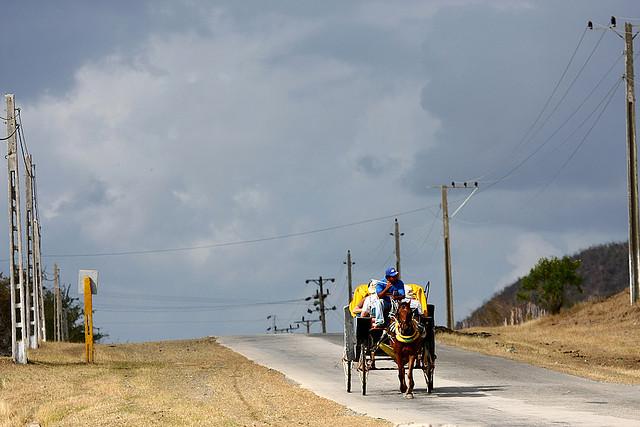Is the sky cloudy?
Concise answer only. Yes. Is it cold in the image?
Keep it brief. No. Is the grass lush?
Concise answer only. No. How many yellow poles?
Keep it brief. 1. 